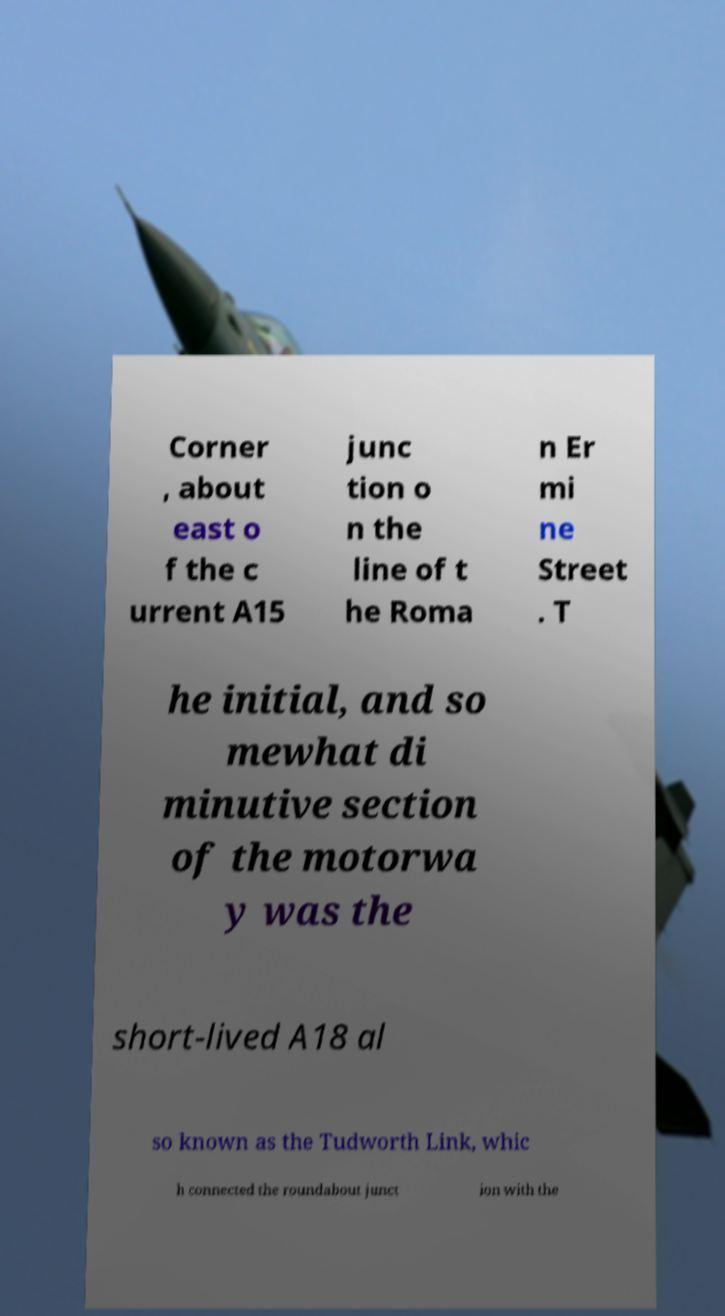Please read and relay the text visible in this image. What does it say? Corner , about east o f the c urrent A15 junc tion o n the line of t he Roma n Er mi ne Street . T he initial, and so mewhat di minutive section of the motorwa y was the short-lived A18 al so known as the Tudworth Link, whic h connected the roundabout junct ion with the 